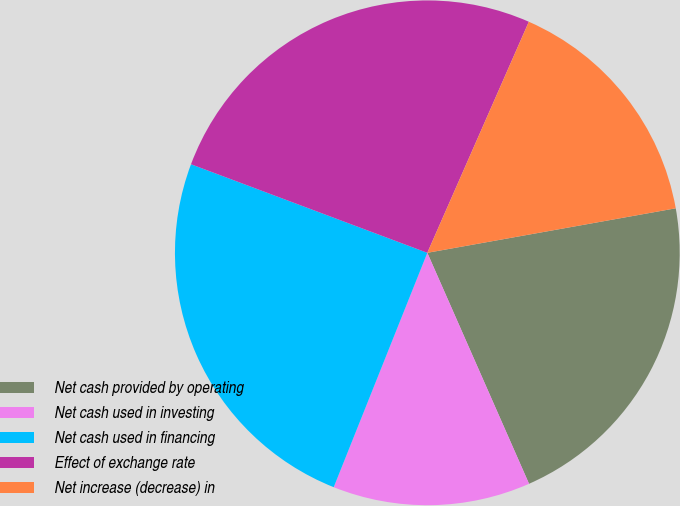Convert chart. <chart><loc_0><loc_0><loc_500><loc_500><pie_chart><fcel>Net cash provided by operating<fcel>Net cash used in investing<fcel>Net cash used in financing<fcel>Effect of exchange rate<fcel>Net increase (decrease) in<nl><fcel>21.22%<fcel>12.65%<fcel>24.66%<fcel>25.88%<fcel>15.59%<nl></chart> 